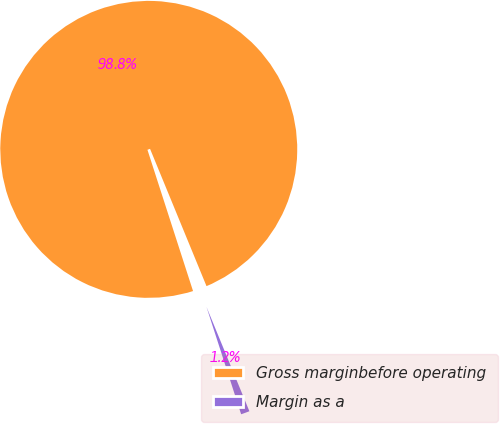Convert chart to OTSL. <chart><loc_0><loc_0><loc_500><loc_500><pie_chart><fcel>Gross marginbefore operating<fcel>Margin as a<nl><fcel>98.76%<fcel>1.24%<nl></chart> 